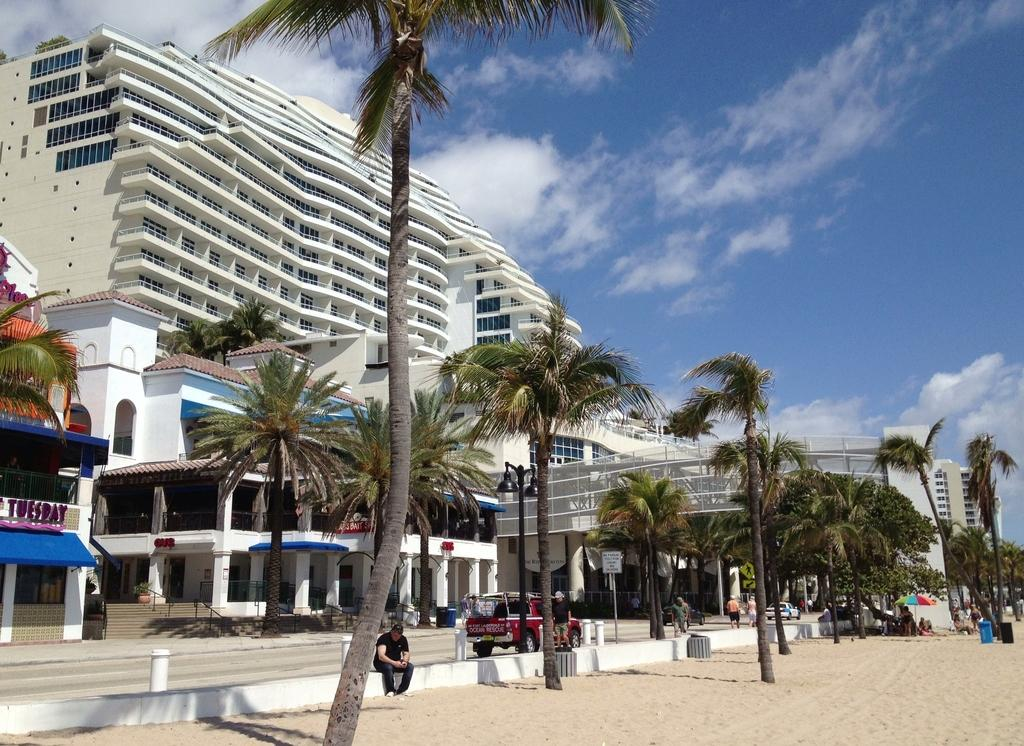What type of terrain is visible in the image? There is sand in the image. What type of vegetation can be seen in the image? There are coconut trees in the image. What type of structures are present in the image? The image contains buildings. What is the color of the sky in the image? The sky is blue in the image. Can you read the note that is lying on the yard in the image? There is no note or yard present in the image; it features sand, coconut trees, buildings, and a blue sky. 